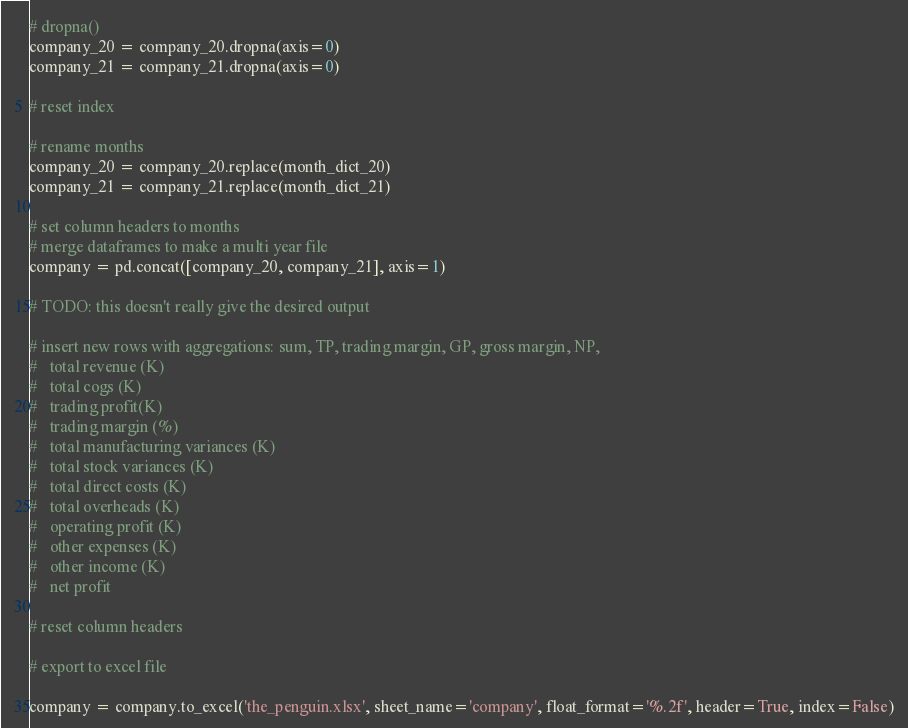Convert code to text. <code><loc_0><loc_0><loc_500><loc_500><_Python_># dropna()
company_20 = company_20.dropna(axis=0)
company_21 = company_21.dropna(axis=0)

# reset index

# rename months
company_20 = company_20.replace(month_dict_20)
company_21 = company_21.replace(month_dict_21)

# set column headers to months
# merge dataframes to make a multi year file
company = pd.concat([company_20, company_21], axis=1)

# TODO: this doesn't really give the desired output

# insert new rows with aggregations: sum, TP, trading margin, GP, gross margin, NP,
#   total revenue (K)
#   total cogs (K)
#   trading profit(K)
#   trading margin (%)
#   total manufacturing variances (K)
#   total stock variances (K)
#   total direct costs (K)
#   total overheads (K)
#   operating profit (K)
#   other expenses (K)
#   other income (K)
#   net profit

# reset column headers

# export to excel file

company = company.to_excel('the_penguin.xlsx', sheet_name='company', float_format='%.2f', header=True, index=False)

</code> 